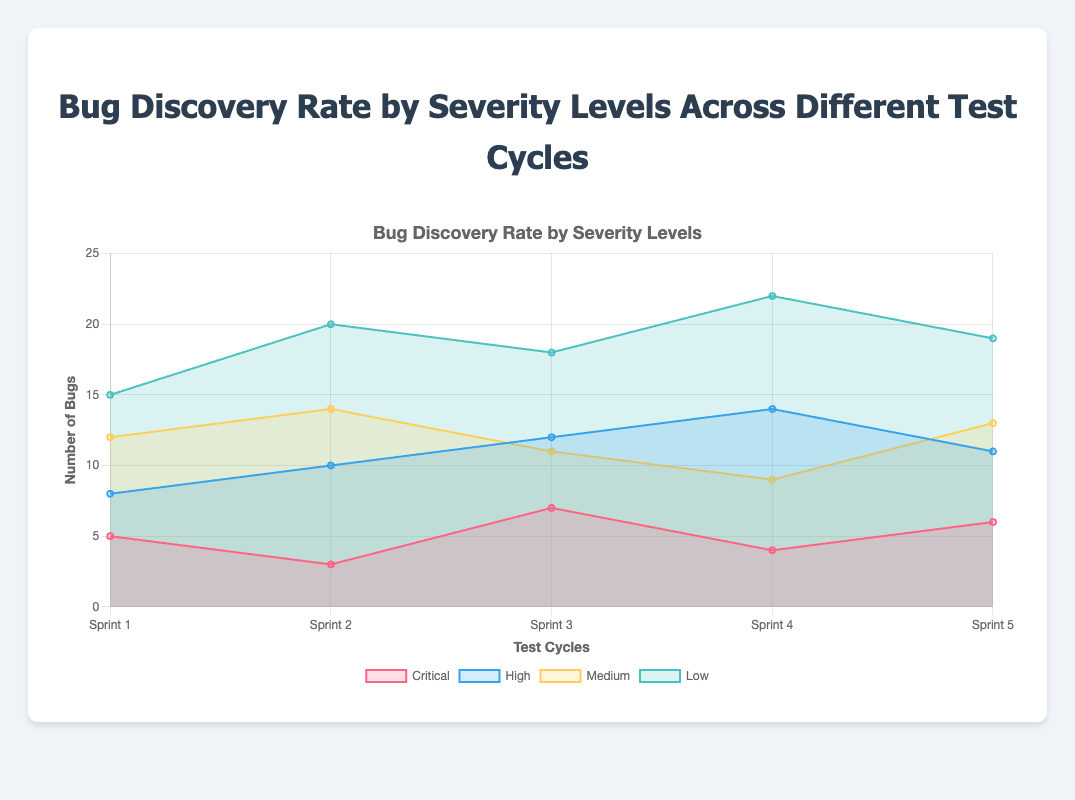What is the title of the chart? The title is prominently displayed at the top of the chart. It summarizes the content of the chart, showing what data is being visualized and compared.
Answer: Bug Discovery Rate by Severity Levels Across Different Test Cycles Which severity level had the highest number of bugs in Sprint 1? We need to look at Sprint 1 and identify which severity level has the highest value among Critical (5), High (8), Medium (12), and Low (15).
Answer: Low What is the total number of bugs found in Sprint 2? Sum the number of bugs at each severity level in Sprint 2: Critical (3) + High (10) + Medium (14) + Low (20).
Answer: 47 How does the number of Critical bugs change from Sprint 2 to Sprint 3? Compare the Critical bugs from Sprint 2 (3 bugs) to Sprint 3 (7 bugs). The change is the difference between these two values (7 - 3).
Answer: Increases by 4 Which Sprint reported the highest number of High severity bugs? Evaluate the number of High severity bugs in all Sprints: Sprint 1 (8), Sprint 2 (10), Sprint 3 (12), Sprint 4 (14), Sprint 5 (11). The highest is 14 in Sprint 4.
Answer: Sprint 4 Which severity level shows a consistent increasing trend across all Sprints? Evaluate the trends of each severity level (Critical, High, Medium, Low) across all Sprints. Medium shows fluctuating values, while Low (15, 20, 18, 22, 19) generally increases but fluctuates, Critical (5, 3, 7, 4, 6) fluctuates, High (8, 10, 12, 14, 11) shows a general increasing trend with slight fluctuation.
Answer: High How many more Medium severity bugs were found in Sprint 5 compared to Sprint 4? Identify the number of Medium bugs in Sprint 4 (9) and Sprint 5 (13). Calculate the difference (13 - 9).
Answer: 4 more Which Sprint had the smallest number of Critical bugs? Examine the number of Critical bugs in all Sprints (Sprint 1: 5, Sprint 2: 3, Sprint 3: 7, Sprint 4: 4, Sprint 5: 6). The smallest number is 3 in Sprint 2.
Answer: Sprint 2 